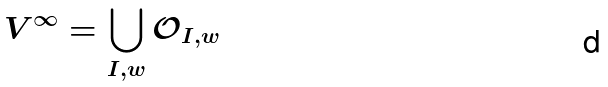Convert formula to latex. <formula><loc_0><loc_0><loc_500><loc_500>V ^ { \infty } = \bigcup _ { I , w } \mathcal { O } _ { I , w }</formula> 